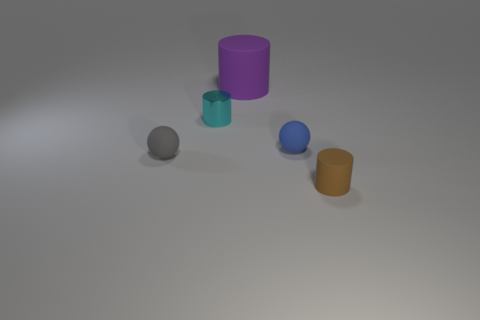Add 4 small red cubes. How many objects exist? 9 Subtract all small brown matte cylinders. How many cylinders are left? 2 Subtract all cyan cylinders. How many cylinders are left? 2 Subtract all cylinders. How many objects are left? 2 Subtract 1 cylinders. How many cylinders are left? 2 Add 3 tiny cyan cylinders. How many tiny cyan cylinders exist? 4 Subtract 1 blue balls. How many objects are left? 4 Subtract all red cylinders. Subtract all brown blocks. How many cylinders are left? 3 Subtract all green spheres. How many gray cylinders are left? 0 Subtract all small blue spheres. Subtract all gray blocks. How many objects are left? 4 